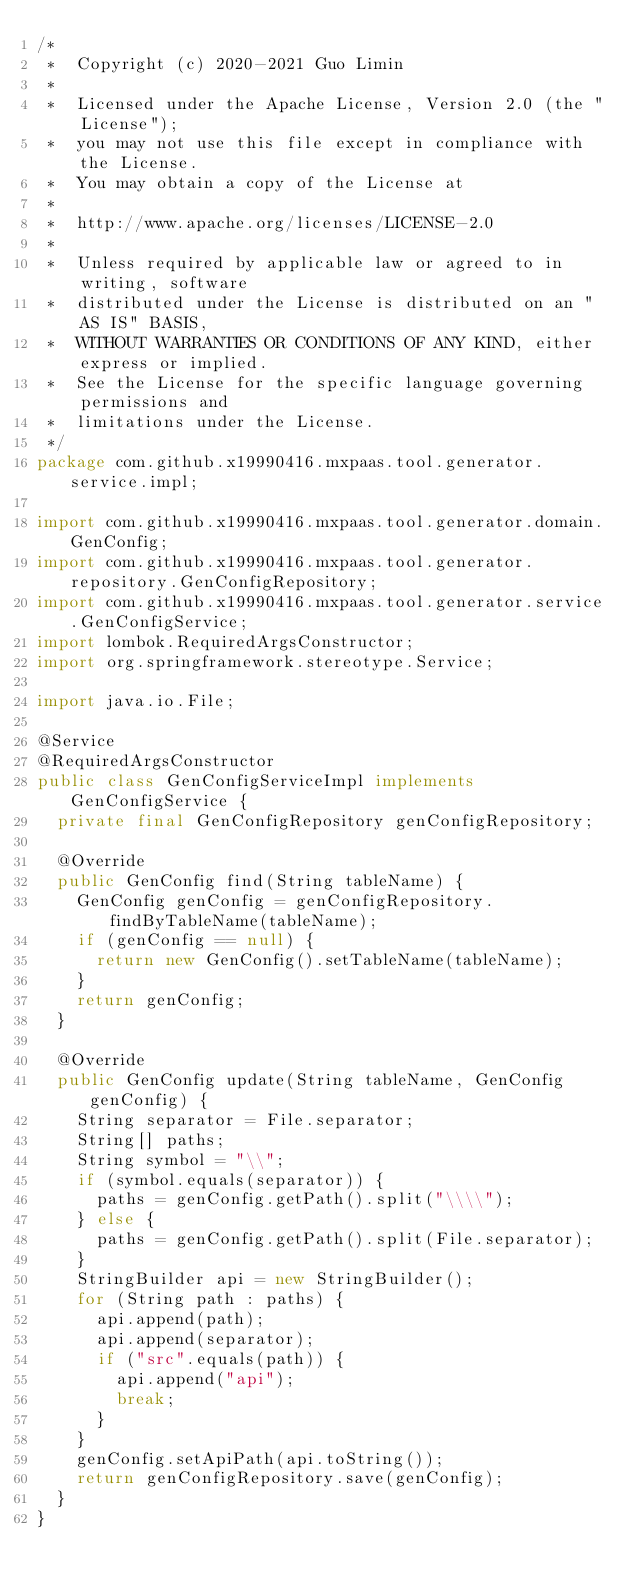Convert code to text. <code><loc_0><loc_0><loc_500><loc_500><_Java_>/*
 *  Copyright (c) 2020-2021 Guo Limin
 *
 *  Licensed under the Apache License, Version 2.0 (the "License");
 *  you may not use this file except in compliance with the License.
 *  You may obtain a copy of the License at
 *
 *  http://www.apache.org/licenses/LICENSE-2.0
 *
 *  Unless required by applicable law or agreed to in writing, software
 *  distributed under the License is distributed on an "AS IS" BASIS,
 *  WITHOUT WARRANTIES OR CONDITIONS OF ANY KIND, either express or implied.
 *  See the License for the specific language governing permissions and
 *  limitations under the License.
 */
package com.github.x19990416.mxpaas.tool.generator.service.impl;

import com.github.x19990416.mxpaas.tool.generator.domain.GenConfig;
import com.github.x19990416.mxpaas.tool.generator.repository.GenConfigRepository;
import com.github.x19990416.mxpaas.tool.generator.service.GenConfigService;
import lombok.RequiredArgsConstructor;
import org.springframework.stereotype.Service;

import java.io.File;

@Service
@RequiredArgsConstructor
public class GenConfigServiceImpl implements GenConfigService {
  private final GenConfigRepository genConfigRepository;

  @Override
  public GenConfig find(String tableName) {
    GenConfig genConfig = genConfigRepository.findByTableName(tableName);
    if (genConfig == null) {
      return new GenConfig().setTableName(tableName);
    }
    return genConfig;
  }

  @Override
  public GenConfig update(String tableName, GenConfig genConfig) {
    String separator = File.separator;
    String[] paths;
    String symbol = "\\";
    if (symbol.equals(separator)) {
      paths = genConfig.getPath().split("\\\\");
    } else {
      paths = genConfig.getPath().split(File.separator);
    }
    StringBuilder api = new StringBuilder();
    for (String path : paths) {
      api.append(path);
      api.append(separator);
      if ("src".equals(path)) {
        api.append("api");
        break;
      }
    }
    genConfig.setApiPath(api.toString());
    return genConfigRepository.save(genConfig);
  }
}
</code> 